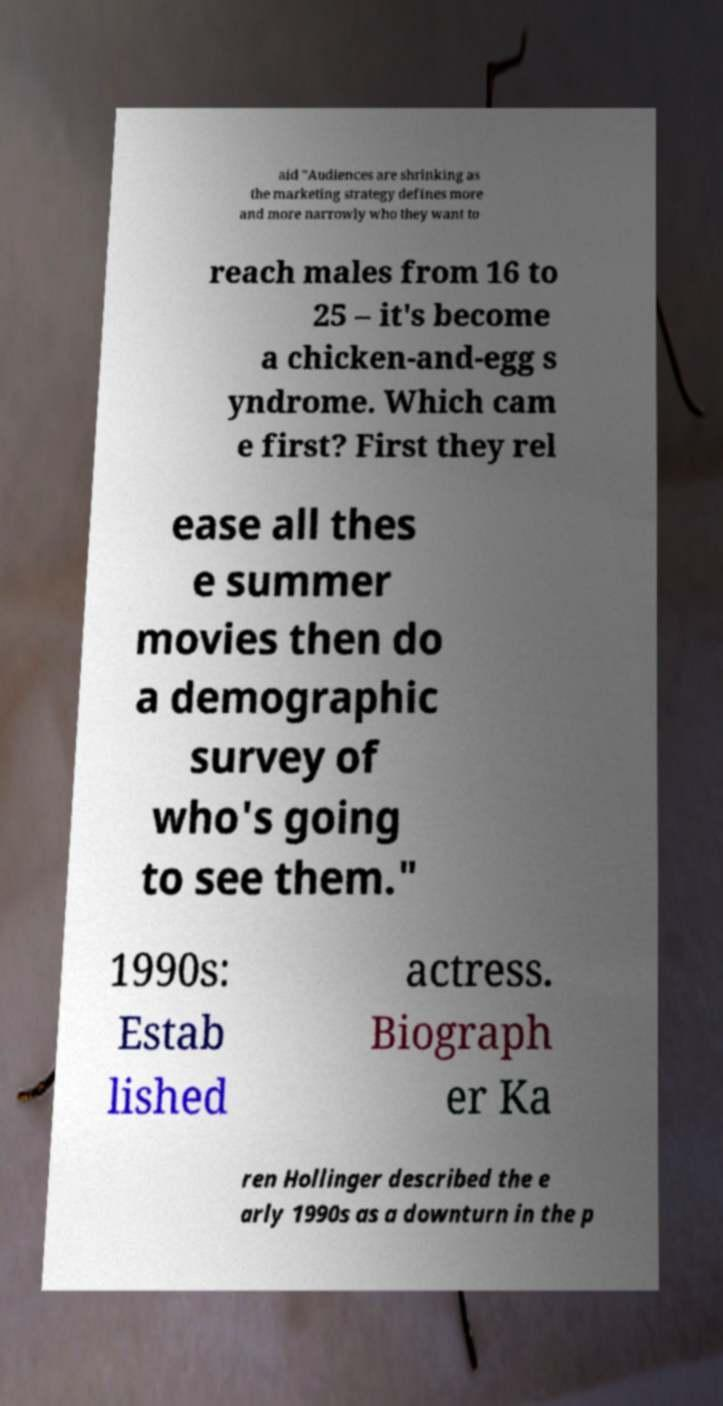I need the written content from this picture converted into text. Can you do that? aid "Audiences are shrinking as the marketing strategy defines more and more narrowly who they want to reach males from 16 to 25 – it's become a chicken-and-egg s yndrome. Which cam e first? First they rel ease all thes e summer movies then do a demographic survey of who's going to see them." 1990s: Estab lished actress. Biograph er Ka ren Hollinger described the e arly 1990s as a downturn in the p 